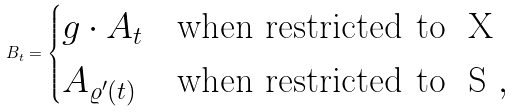Convert formula to latex. <formula><loc_0><loc_0><loc_500><loc_500>B _ { t } = \begin{cases} g \cdot A _ { t } & \text {when restricted to } $ X $ \\ A _ { \varrho ^ { \prime } ( t ) } & \text {when restricted to } $ S $ , \end{cases}</formula> 